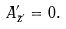<formula> <loc_0><loc_0><loc_500><loc_500>A ^ { \prime } _ { \bar { z } ^ { \prime } } = 0 .</formula> 